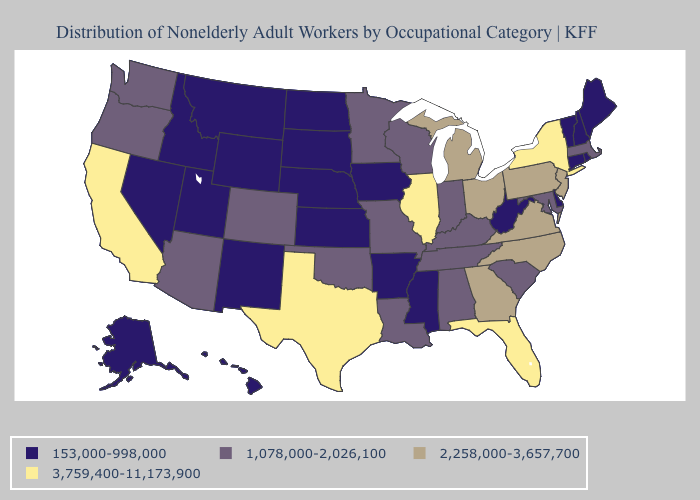Does North Carolina have a lower value than Tennessee?
Concise answer only. No. Does Ohio have the lowest value in the MidWest?
Short answer required. No. How many symbols are there in the legend?
Concise answer only. 4. Is the legend a continuous bar?
Concise answer only. No. What is the highest value in the MidWest ?
Be succinct. 3,759,400-11,173,900. How many symbols are there in the legend?
Concise answer only. 4. What is the lowest value in the West?
Concise answer only. 153,000-998,000. What is the value of Mississippi?
Short answer required. 153,000-998,000. Name the states that have a value in the range 2,258,000-3,657,700?
Short answer required. Georgia, Michigan, New Jersey, North Carolina, Ohio, Pennsylvania, Virginia. What is the highest value in the West ?
Give a very brief answer. 3,759,400-11,173,900. Does North Carolina have the same value as New Jersey?
Short answer required. Yes. Name the states that have a value in the range 1,078,000-2,026,100?
Give a very brief answer. Alabama, Arizona, Colorado, Indiana, Kentucky, Louisiana, Maryland, Massachusetts, Minnesota, Missouri, Oklahoma, Oregon, South Carolina, Tennessee, Washington, Wisconsin. What is the value of Louisiana?
Answer briefly. 1,078,000-2,026,100. Does Minnesota have a lower value than Rhode Island?
Answer briefly. No. What is the value of Pennsylvania?
Write a very short answer. 2,258,000-3,657,700. 